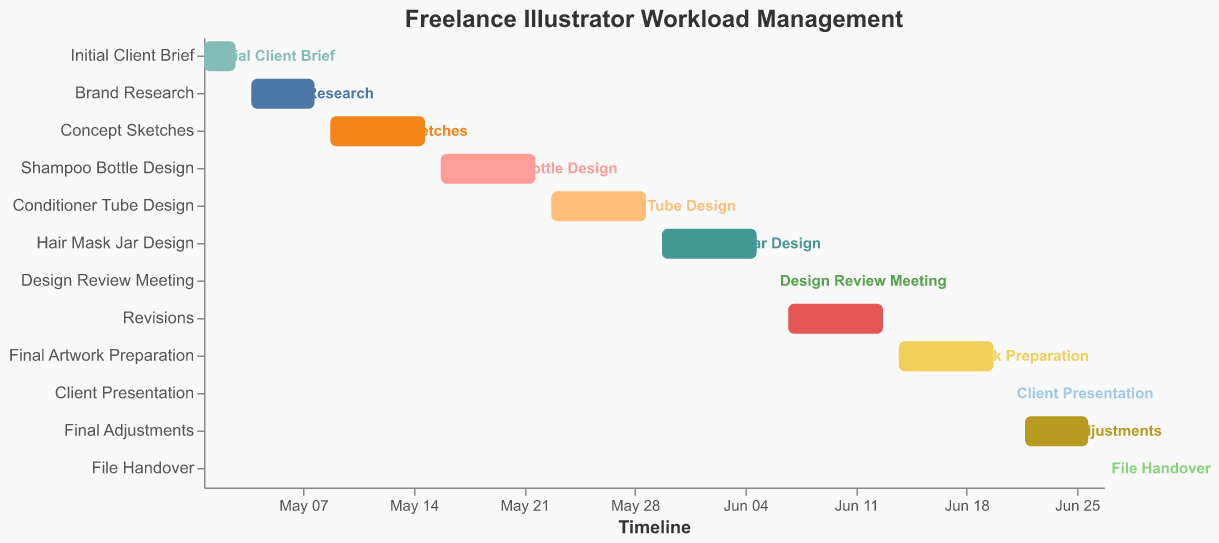What is the title of the Gantt Chart? The title of a chart is usually above the chart and describes what the chart is about. In this case, the title "Freelance Illustrator Workload Management" can be directly seen at the top of the figure.
Answer: Freelance Illustrator Workload Management What is the timeline range displayed on the x-axis? The x-axis in a Gantt Chart represents the timeline. By looking at the start and end dates of the tasks, the timeline ranges from the "Start Date" of the earliest task to the "End Date" of the latest task, which is May 1, 2023, to June 27, 2023.
Answer: May 1, 2023, to June 27, 2023 Which task lasts the longest? To determine the longest task, look at the difference between the start and end dates of each task. Among the tasks, "Revisions" (from June 7 to June 13) spans 7 days, which is the longest duration.
Answer: Revisions How many tasks are there in total? The number of tasks can be counted directly from the y-axis where each unique task is listed. The chart lists 12 tasks in total.
Answer: 12 Which tasks are scheduled for a single day? Tasks that last only one day have the same start and end dates. By examining the start and end dates, "Design Review Meeting," "Client Presentation," and "File Handover" are each scheduled for a single day (June 6, June 21, and June 27, respectively).
Answer: Design Review Meeting, Client Presentation, File Handover Which task follows the "Concept Sketches"? Since tasks are listed in chronological order on the y-axis of the Gantt Chart, the task that follows "Concept Sketches" is "Shampoo Bottle Design." This can be determined by looking at the position immediately after "Concept Sketches" on the y-axis.
Answer: Shampoo Bottle Design What is the duration of the "Final Adjustments" task? The duration of a task is the difference between its end date and start date, plus one day (since start and end dates are inclusive). For "Final Adjustments," it starts on June 22 and ends on June 26, so the duration is (June 26 - June 22) + 1 = 5 days.
Answer: 5 days How many tasks are part of the design phase (including sketches and individual product designs)? By examining the task names, tasks related to the design phase include "Concept Sketches," "Shampoo Bottle Design," "Conditioner Tube Design," and "Hair Mask Jar Design." Counting these tasks gives a total of 4 tasks.
Answer: 4 How does the start of "Revisions" relate to the end of "Design Review Meeting"? Comparing the end date of "Design Review Meeting" (June 6) with the start date of "Revisions" (June 7), "Revisions" begins immediately the next day after the "Design Review Meeting."
Answer: The next day Which task takes place directly before the "Client Presentation"? Looking at the task sequence on the y-axis, the task immediately above "Client Presentation" is "Final Artwork Preparation," indicating it takes place directly before the "Client Presentation."
Answer: Final Artwork Preparation 